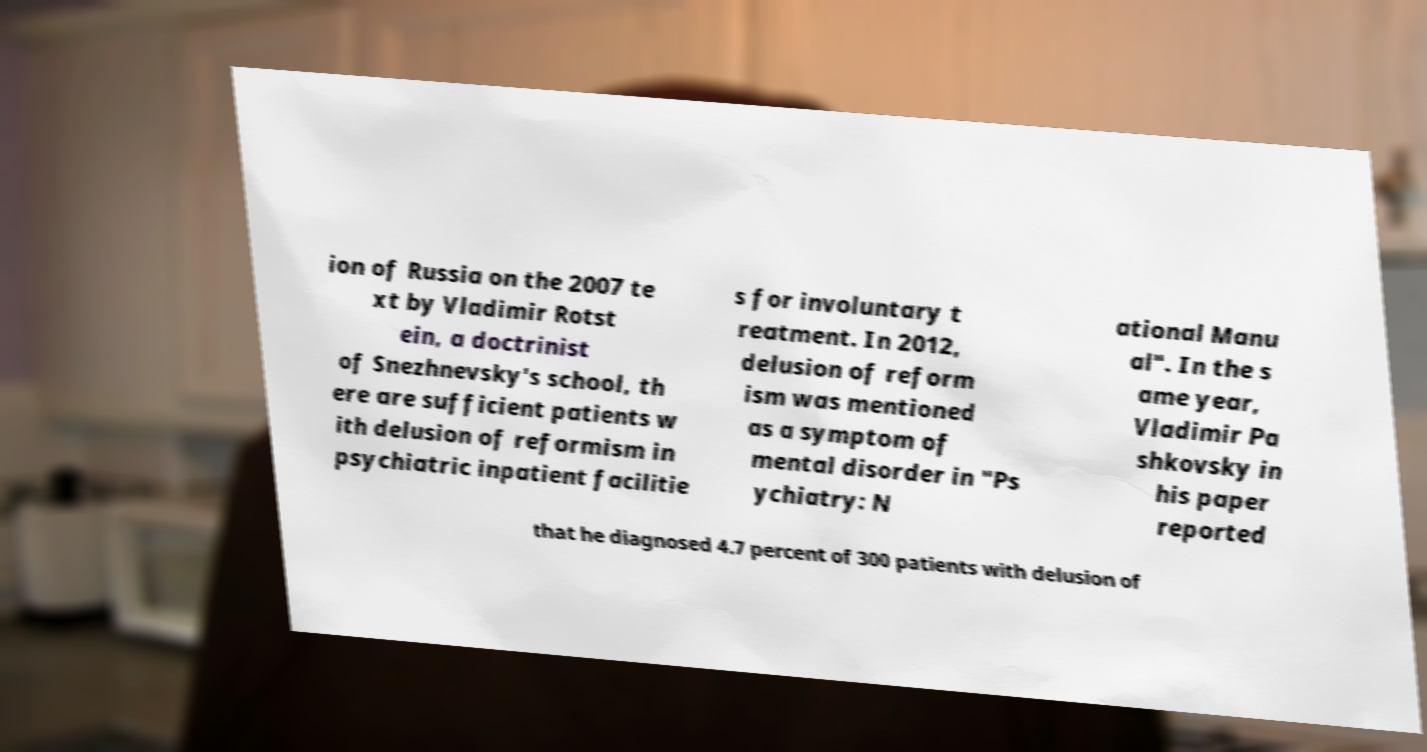For documentation purposes, I need the text within this image transcribed. Could you provide that? ion of Russia on the 2007 te xt by Vladimir Rotst ein, a doctrinist of Snezhnevsky's school, th ere are sufficient patients w ith delusion of reformism in psychiatric inpatient facilitie s for involuntary t reatment. In 2012, delusion of reform ism was mentioned as a symptom of mental disorder in "Ps ychiatry: N ational Manu al". In the s ame year, Vladimir Pa shkovsky in his paper reported that he diagnosed 4.7 percent of 300 patients with delusion of 